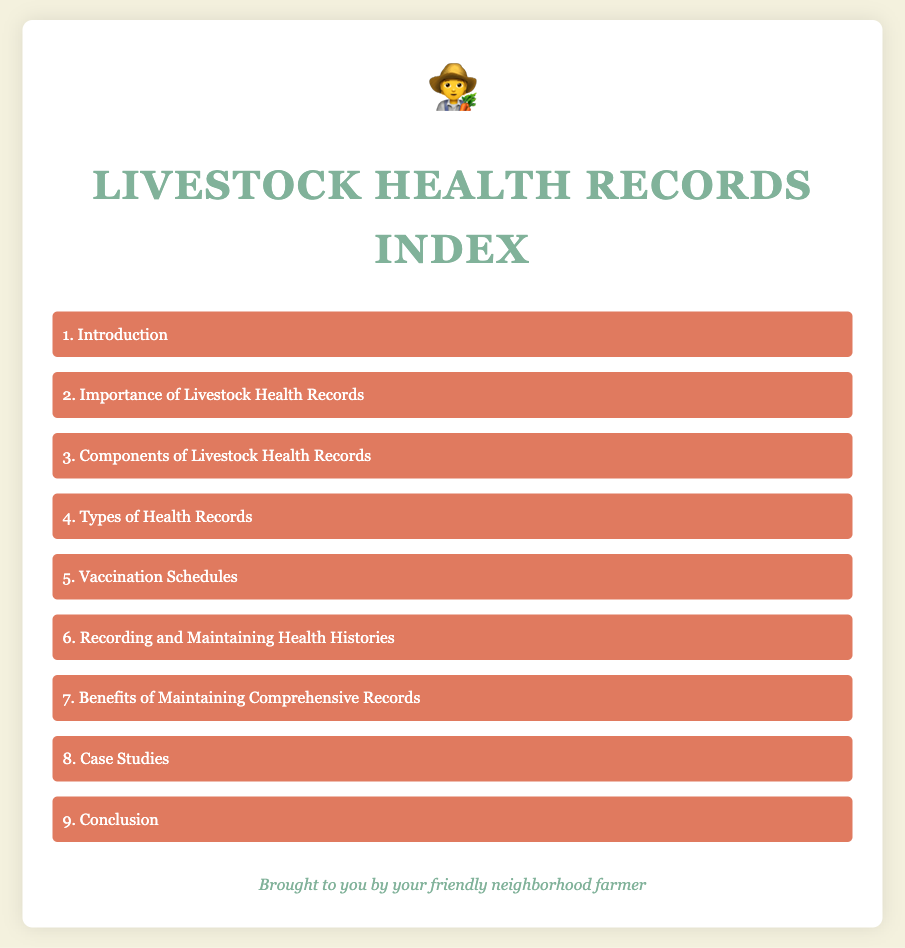What is the title of the document? The title of the document is specified in the `<title>` tag in the HTML, which indicates the main focus of the content.
Answer: Livestock Health Records Index What is the first item in the index list? The first item is listed as the initial entry in the unordered list of the document, representing the introduction to the topic.
Answer: Introduction How many items are in the index list? The number of items is determined by counting each list element within the index in the document.
Answer: 9 What section discusses vaccination schedules? The specific section that addresses vaccination schedules is mentioned by its title within the index list.
Answer: Vaccination Schedules Which section explains the benefits of maintaining records? The section dedicated to explaining the advantages of keeping thorough records is identified in the index list.
Answer: Benefits of Maintaining Comprehensive Records What is the color scheme of the document? The color scheme can be deduced by reviewing the specified color codes used for backgrounds and text throughout the style settings.
Answer: Soft colors What does the farmer icon symbolize in this document? The farmer icon represents the main audience and creates a friendly connection with the content presented.
Answer: A farmer What is emphasized in the second index item? The second item highlights the significance of maintaining documentation related to livestock health.
Answer: Importance of Livestock Health Records What can be found in the case studies section? The case studies section typically includes real-life examples illustrating the application of the discussed topics.
Answer: Real-life examples 